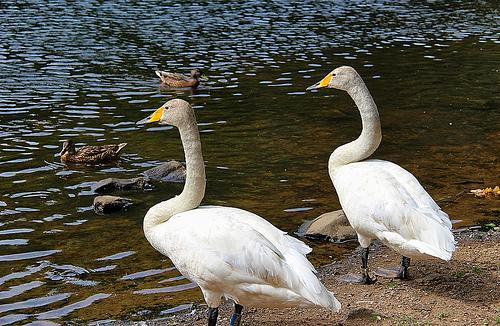List the objects and elements interacting with the water in the image. Ducks, rocks, small black rock, light reflections, and plant material are interacting with the water. State the types of birds in the image and where they are. There are two birds in the image: a white duck standing on the shore and a brown duck floating on the water. Mention the color of the ducks' beaks and necks in the image. The ducks have orange and black beaks and long curved necks. Identify the main focus of the image and describe their activity. A white duck with a long neck is standing on the shore, while a brown duck is floating on the water nearby. Describe the appearance of the water in the image. The water has small ripples on the surface and appears brown with light reflecting off it. Describe the overall mood or sentiment of the image. The image has a calm and peaceful mood, depicting ducks and nature in harmony. What color are the webbed feet of the bird in the image? The webbed feet of the bird are black. What kind of surface is the ground covered in? The ground is covered in brown dirt. How many ducks can be seen in the image? There are two ducks in the image: a white one and a brown one. Is the orange and black beak of the goose shaped like a spiral? There is no mention of the shape of the orange and black beak of the goose, so it's impossible to determine if it's shaped like a spiral. What is the emotion evoked by the image? Calm and peaceful. List the colors of the beaks of the birds in the image. Orange and black, yellow. Which area in the image has light reflecting on the water? The area of light reflecting on water is at X:0 Y:1 Width:495 Height:495. Are there any pink ripples on the surface of the water near the ducks? There is no mention of pink ripples in the surface of the water, only small ripples. How many birds are present in the image? There are four birds. Is there a blue rock submerged in the sandy shore area? There is no mention of a blue rock, nor any rock submerged in the sandy shore area. Read any visible text in the image. There is no visible text in the image. Can you see the red and white stripes on the feathers of the group of geese? There is no mention of red and white striped feathers on any of the geese in the image. Does the image show any shadows? If so, what is casting the shadow? Yes, there is a shadow of a duck on the ground at X:399 Y:256 Width:95 Height:95. Identify the type of bird that has webbed black feet. A water fowl or a duck. How many white geese are on the shore? Two white geese are on the shore. What type of surface is near the body of water? Ground covered in brown dirt and a bit of sandy shore. Is the plant material floating on the surface of the water purple? No, it's not mentioned in the image. Describe the scene in the image. The image shows two white geese and a brown duck near a body of water with rocks and ripples, with light reflecting off of the surface. Are any of the birds interacting with the rocks in the water? No, the birds are not directly interacting with the rocks. Does the brown duck standing on the shore have green feet? The brown duck is floating on water, it is not standing on the shore and there is no mention of green feet. Which bird has a long neck and is white? The large white duck or goose, located at X:303 Y:62 Width:157 Height:157. Find any unusual or unexpected elements in the image. There are no unusual or unexpected elements in the image. Which bird has an orange and black beak? The bird with the orange and black beak is located at X:302 Y:70 Width:30 Height:30. Describe the color of the water. The water looks brown. Rate the quality of the image. The image has decent quality. Is there any plant material visible in the image? Yes, there is plant material floating on the surface of the water at X:469 Y:185 Width:30 Height:30. Identify the bird described as "a duck wading in the water." That would be the brown duck floating on water at X:34 Y:110 Width:112 Height:112 How many rocks are in the water? There are multiple rocks in the water (large stones sticking up). 